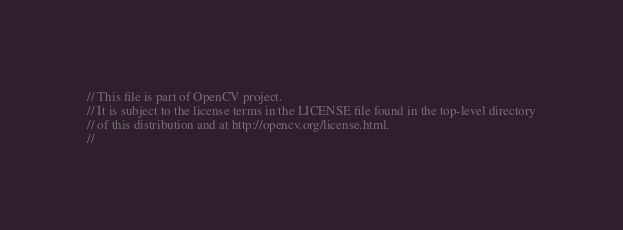Convert code to text. <code><loc_0><loc_0><loc_500><loc_500><_C++_>// This file is part of OpenCV project.
// It is subject to the license terms in the LICENSE file found in the top-level directory
// of this distribution and at http://opencv.org/license.html.
//</code> 